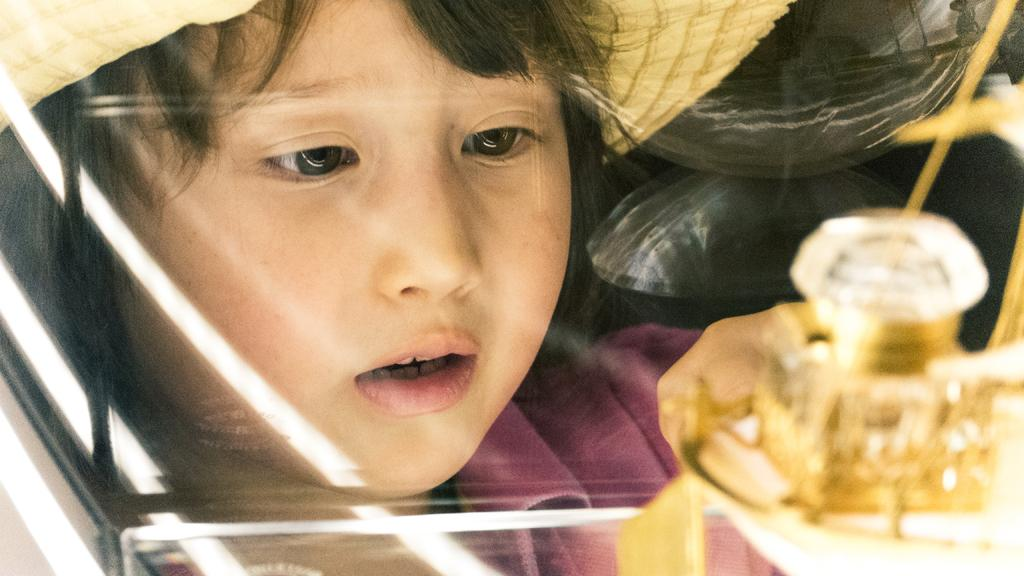Who is the main subject in the image? There is a girl in the image. What is the girl wearing on her head? The girl is wearing a hat. What can be seen in front of the girl? There is a glass object in front of the girl. How many children are playing with the beginner brother in the image? There are no children or brothers mentioned in the image; it only features a girl wearing a hat and a glass object in front of her. 